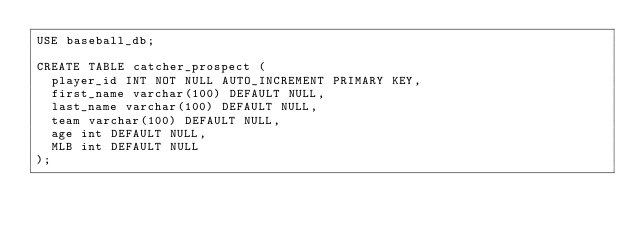<code> <loc_0><loc_0><loc_500><loc_500><_SQL_>USE baseball_db;

CREATE TABLE catcher_prospect (
  player_id INT NOT NULL AUTO_INCREMENT PRIMARY KEY,
  first_name varchar(100) DEFAULT NULL,
  last_name varchar(100) DEFAULT NULL,
  team varchar(100) DEFAULT NULL,
  age int DEFAULT NULL,
  MLB int DEFAULT NULL
);
</code> 